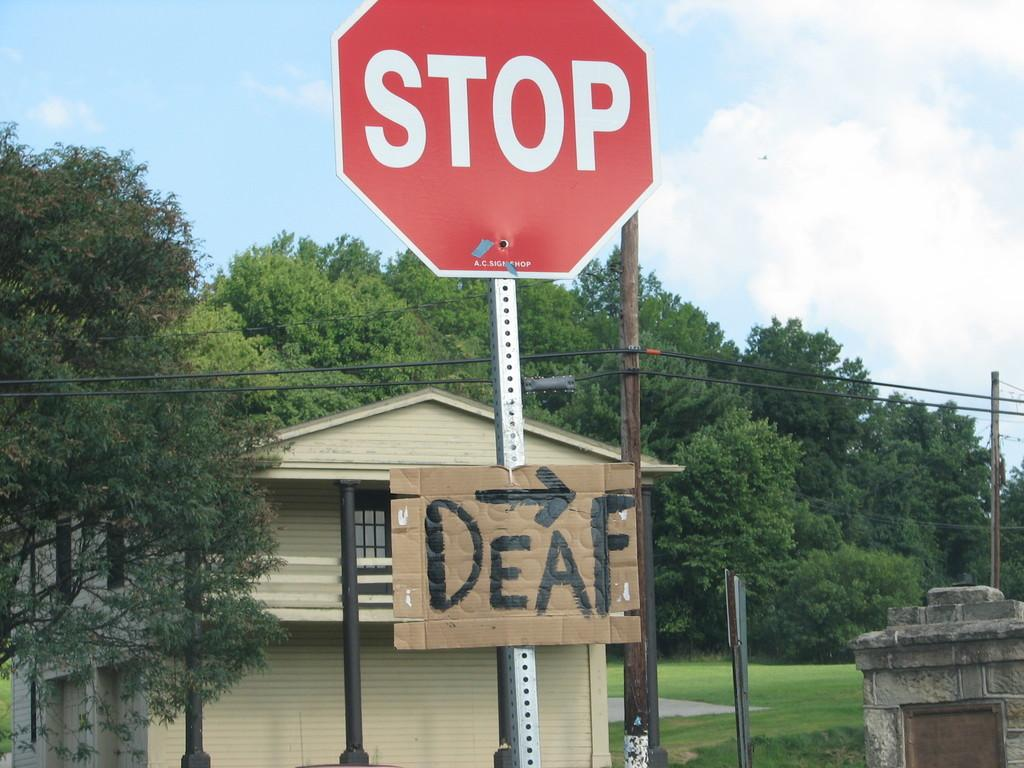Provide a one-sentence caption for the provided image. A stop sign with a cardboard sign underneath that says "Deaf". 